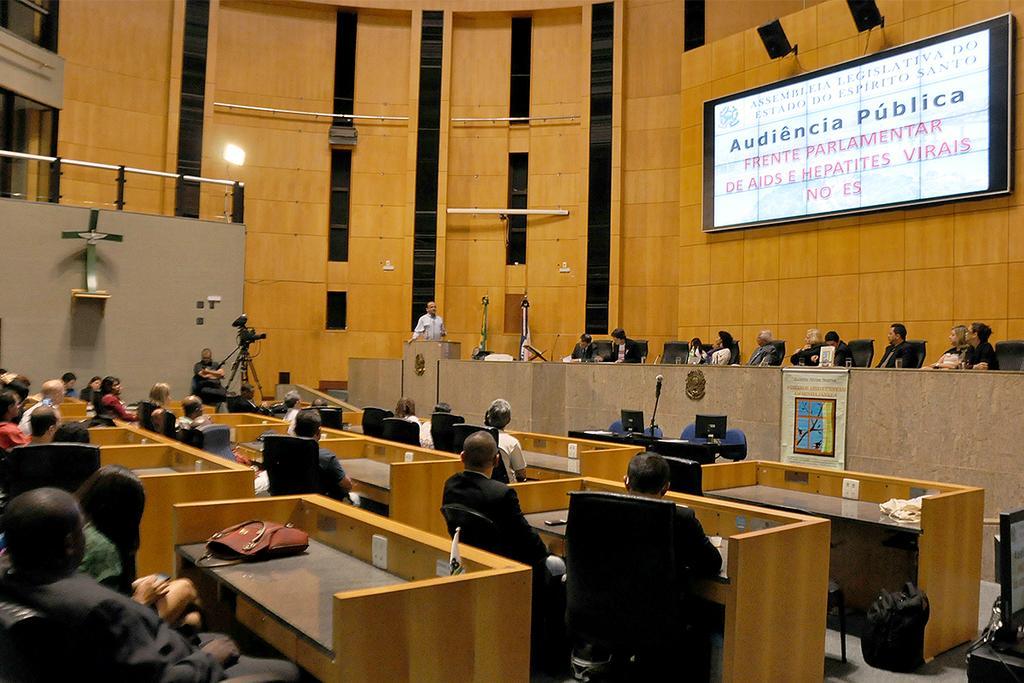Can you describe this image briefly? This picture is clicked inside. There is a Hall which includes group of people, many number of tables and chairs. On the top right there are two speakers and a Projector screen that are wall mounted. On the bottom right there is a Monitor placed on the top of the table and there is a bag which is placed on the ground. On the right there is a microphone and two Monitors attached to the table. In the center there is a Man standing behind the Podium. In the foreground we can see group of people sitting on the chair. On the left there is a bag placed on the top of the table and there is a Camera which is attached to the stand. In the background there is a wall and a focusing light. 